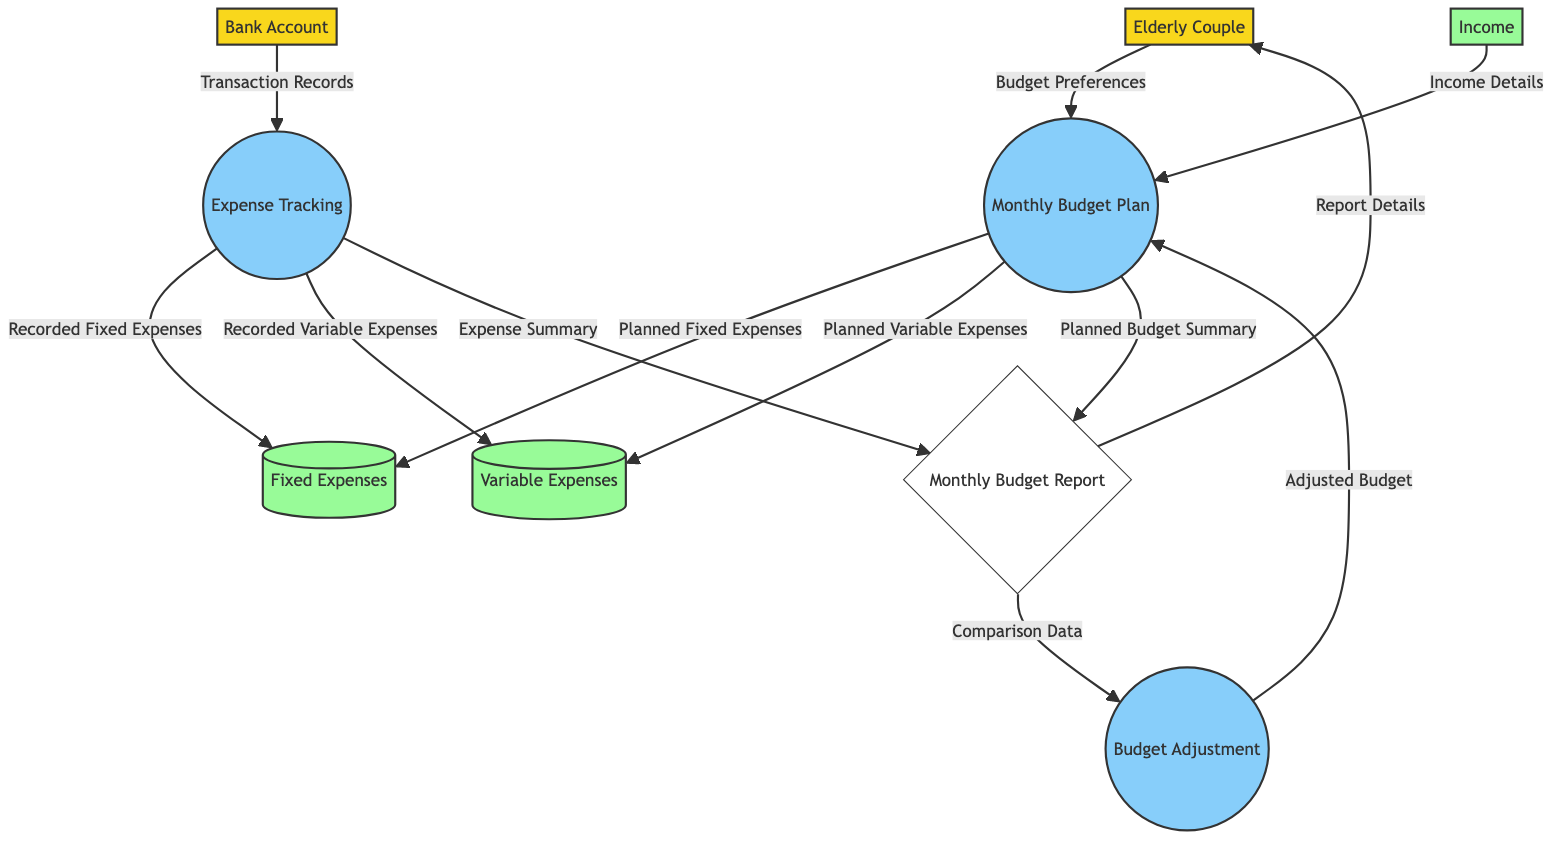What is the main role of the "Elderly Couple"? The "Elderly Couple" is labeled as an external entity, representing the main actors involved in managing the household budget and expenses.
Answer: The main actors who manage the household budget and expenses How many data stores are there in the diagram? The diagram contains three data stores: "Fixed Expenses," "Variable Expenses," and "Income."
Answer: Three Which process receives "Transaction Records"? The "Expense Tracking" process receives "Transaction Records" as input from the "Bank Account" external entity.
Answer: Expense Tracking What flows from the "Monthly Budget Report" to the "Elderly Couple"? The data flow from the "Monthly Budget Report" to the "Elderly Couple" contains "Report Details."
Answer: Report Details What types of expenses are recorded by "Expense Tracking"? The "Expense Tracking" process records "Fixed Expenses" and "Variable Expenses" as detailed in the data flows.
Answer: Fixed Expenses and Variable Expenses How does the budget get adjusted? The "Budget Adjustment" process takes information from the "Monthly Budget Report" and sends "Adjusted Budget" data back to the "Monthly Budget Plan."
Answer: By comparing data from the report What data gets sent from "Monthly Budget Plan" to "Monthly Budget Report"? The "Monthly Budget Plan" sends both "Planned Budget Summary" and details on "Planned Fixed Expenses" and "Planned Variable Expenses" to the "Monthly Budget Report."
Answer: Planned Budget Summary What is the first input into the "Monthly Budget Plan"? The first input is "Budget Preferences" provided by the "Elderly Couple" external entity.
Answer: Budget Preferences Which entity sends "Expense Summary" to the "Monthly Budget Report"? The "Expense Tracking" process sends the "Expense Summary" to the "Monthly Budget Report."
Answer: Expense Tracking 